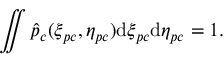Convert formula to latex. <formula><loc_0><loc_0><loc_500><loc_500>\iint \hat { p } _ { c } ( \xi _ { p c } , \eta _ { p c } ) d \xi _ { p c } d \eta _ { p c } = 1 .</formula> 